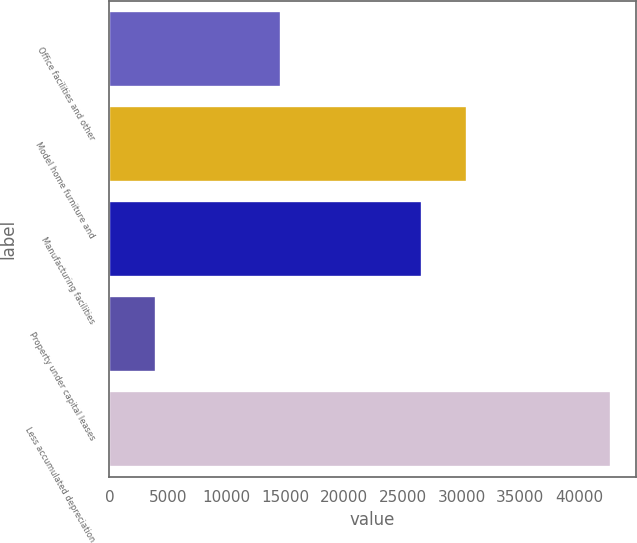Convert chart. <chart><loc_0><loc_0><loc_500><loc_500><bar_chart><fcel>Office facilities and other<fcel>Model home furniture and<fcel>Manufacturing facilities<fcel>Property under capital leases<fcel>Less accumulated depreciation<nl><fcel>14636<fcel>30463.1<fcel>26592<fcel>4005<fcel>42716<nl></chart> 